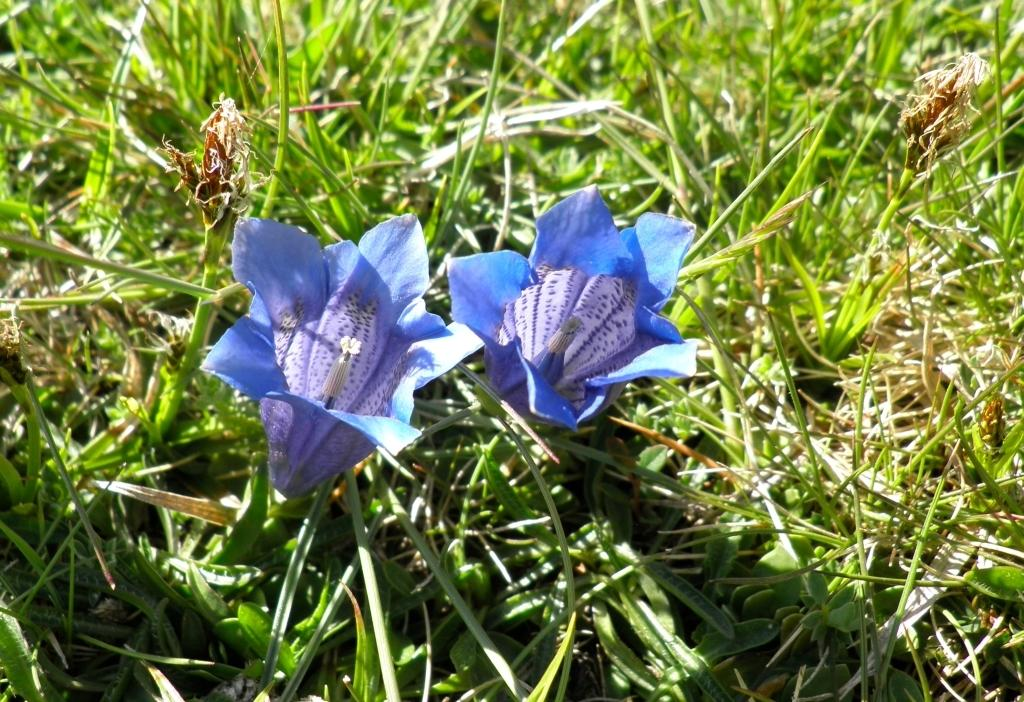What type of plants can be seen in the image? There are flowers in the image. What can be seen in the background of the image? There is grass visible in the background of the image. What thought is the flower having in the image? Flowers do not have thoughts, as they are plants and not capable of thinking. 